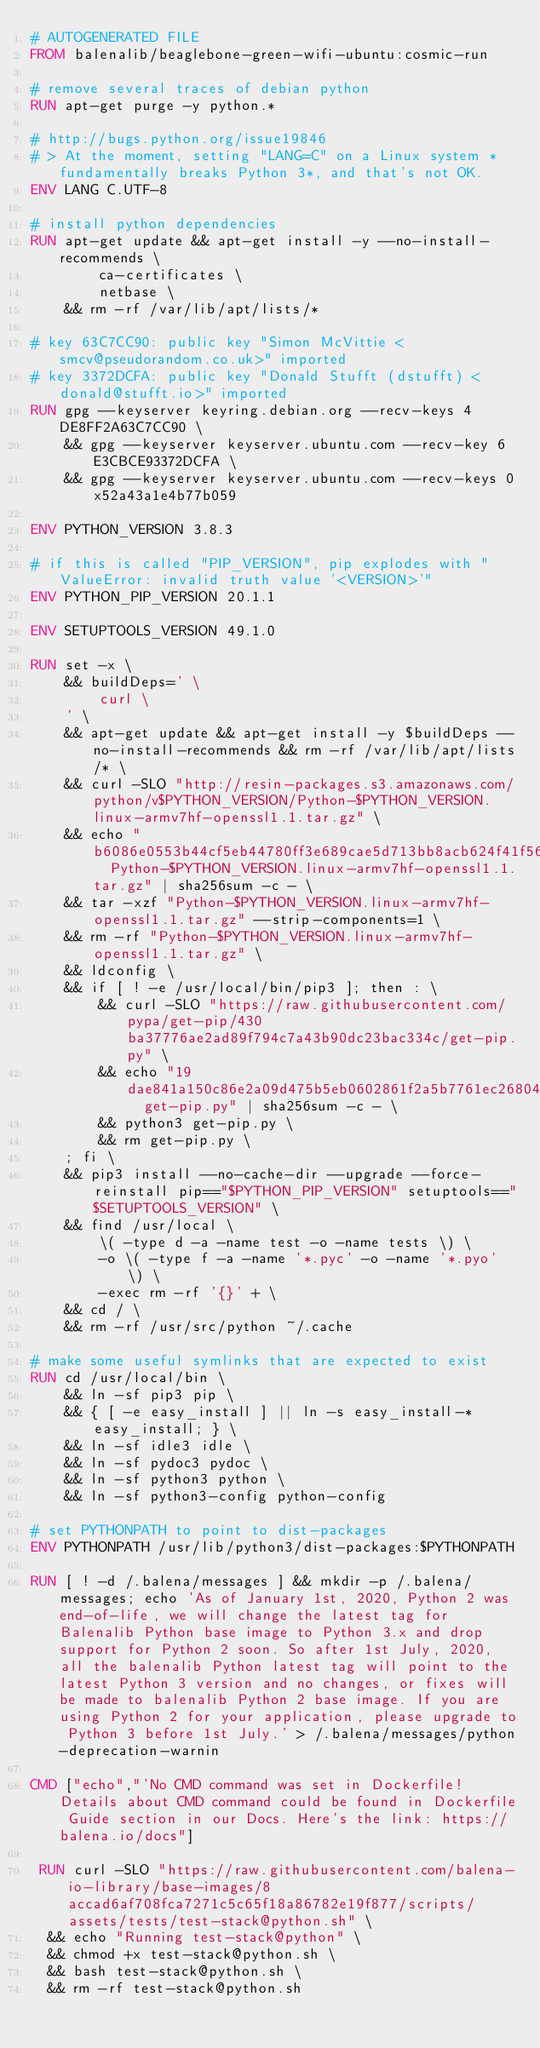Convert code to text. <code><loc_0><loc_0><loc_500><loc_500><_Dockerfile_># AUTOGENERATED FILE
FROM balenalib/beaglebone-green-wifi-ubuntu:cosmic-run

# remove several traces of debian python
RUN apt-get purge -y python.*

# http://bugs.python.org/issue19846
# > At the moment, setting "LANG=C" on a Linux system *fundamentally breaks Python 3*, and that's not OK.
ENV LANG C.UTF-8

# install python dependencies
RUN apt-get update && apt-get install -y --no-install-recommends \
		ca-certificates \
		netbase \
	&& rm -rf /var/lib/apt/lists/*

# key 63C7CC90: public key "Simon McVittie <smcv@pseudorandom.co.uk>" imported
# key 3372DCFA: public key "Donald Stufft (dstufft) <donald@stufft.io>" imported
RUN gpg --keyserver keyring.debian.org --recv-keys 4DE8FF2A63C7CC90 \
	&& gpg --keyserver keyserver.ubuntu.com --recv-key 6E3CBCE93372DCFA \
	&& gpg --keyserver keyserver.ubuntu.com --recv-keys 0x52a43a1e4b77b059

ENV PYTHON_VERSION 3.8.3

# if this is called "PIP_VERSION", pip explodes with "ValueError: invalid truth value '<VERSION>'"
ENV PYTHON_PIP_VERSION 20.1.1

ENV SETUPTOOLS_VERSION 49.1.0

RUN set -x \
	&& buildDeps=' \
		curl \
	' \
	&& apt-get update && apt-get install -y $buildDeps --no-install-recommends && rm -rf /var/lib/apt/lists/* \
	&& curl -SLO "http://resin-packages.s3.amazonaws.com/python/v$PYTHON_VERSION/Python-$PYTHON_VERSION.linux-armv7hf-openssl1.1.tar.gz" \
	&& echo "b6086e0553b44cf5eb44780ff3e689cae5d713bb8acb624f41f566fd7a4b19df  Python-$PYTHON_VERSION.linux-armv7hf-openssl1.1.tar.gz" | sha256sum -c - \
	&& tar -xzf "Python-$PYTHON_VERSION.linux-armv7hf-openssl1.1.tar.gz" --strip-components=1 \
	&& rm -rf "Python-$PYTHON_VERSION.linux-armv7hf-openssl1.1.tar.gz" \
	&& ldconfig \
	&& if [ ! -e /usr/local/bin/pip3 ]; then : \
		&& curl -SLO "https://raw.githubusercontent.com/pypa/get-pip/430ba37776ae2ad89f794c7a43b90dc23bac334c/get-pip.py" \
		&& echo "19dae841a150c86e2a09d475b5eb0602861f2a5b7761ec268049a662dbd2bd0c  get-pip.py" | sha256sum -c - \
		&& python3 get-pip.py \
		&& rm get-pip.py \
	; fi \
	&& pip3 install --no-cache-dir --upgrade --force-reinstall pip=="$PYTHON_PIP_VERSION" setuptools=="$SETUPTOOLS_VERSION" \
	&& find /usr/local \
		\( -type d -a -name test -o -name tests \) \
		-o \( -type f -a -name '*.pyc' -o -name '*.pyo' \) \
		-exec rm -rf '{}' + \
	&& cd / \
	&& rm -rf /usr/src/python ~/.cache

# make some useful symlinks that are expected to exist
RUN cd /usr/local/bin \
	&& ln -sf pip3 pip \
	&& { [ -e easy_install ] || ln -s easy_install-* easy_install; } \
	&& ln -sf idle3 idle \
	&& ln -sf pydoc3 pydoc \
	&& ln -sf python3 python \
	&& ln -sf python3-config python-config

# set PYTHONPATH to point to dist-packages
ENV PYTHONPATH /usr/lib/python3/dist-packages:$PYTHONPATH

RUN [ ! -d /.balena/messages ] && mkdir -p /.balena/messages; echo 'As of January 1st, 2020, Python 2 was end-of-life, we will change the latest tag for Balenalib Python base image to Python 3.x and drop support for Python 2 soon. So after 1st July, 2020, all the balenalib Python latest tag will point to the latest Python 3 version and no changes, or fixes will be made to balenalib Python 2 base image. If you are using Python 2 for your application, please upgrade to Python 3 before 1st July.' > /.balena/messages/python-deprecation-warnin

CMD ["echo","'No CMD command was set in Dockerfile! Details about CMD command could be found in Dockerfile Guide section in our Docs. Here's the link: https://balena.io/docs"]

 RUN curl -SLO "https://raw.githubusercontent.com/balena-io-library/base-images/8accad6af708fca7271c5c65f18a86782e19f877/scripts/assets/tests/test-stack@python.sh" \
  && echo "Running test-stack@python" \
  && chmod +x test-stack@python.sh \
  && bash test-stack@python.sh \
  && rm -rf test-stack@python.sh 
</code> 